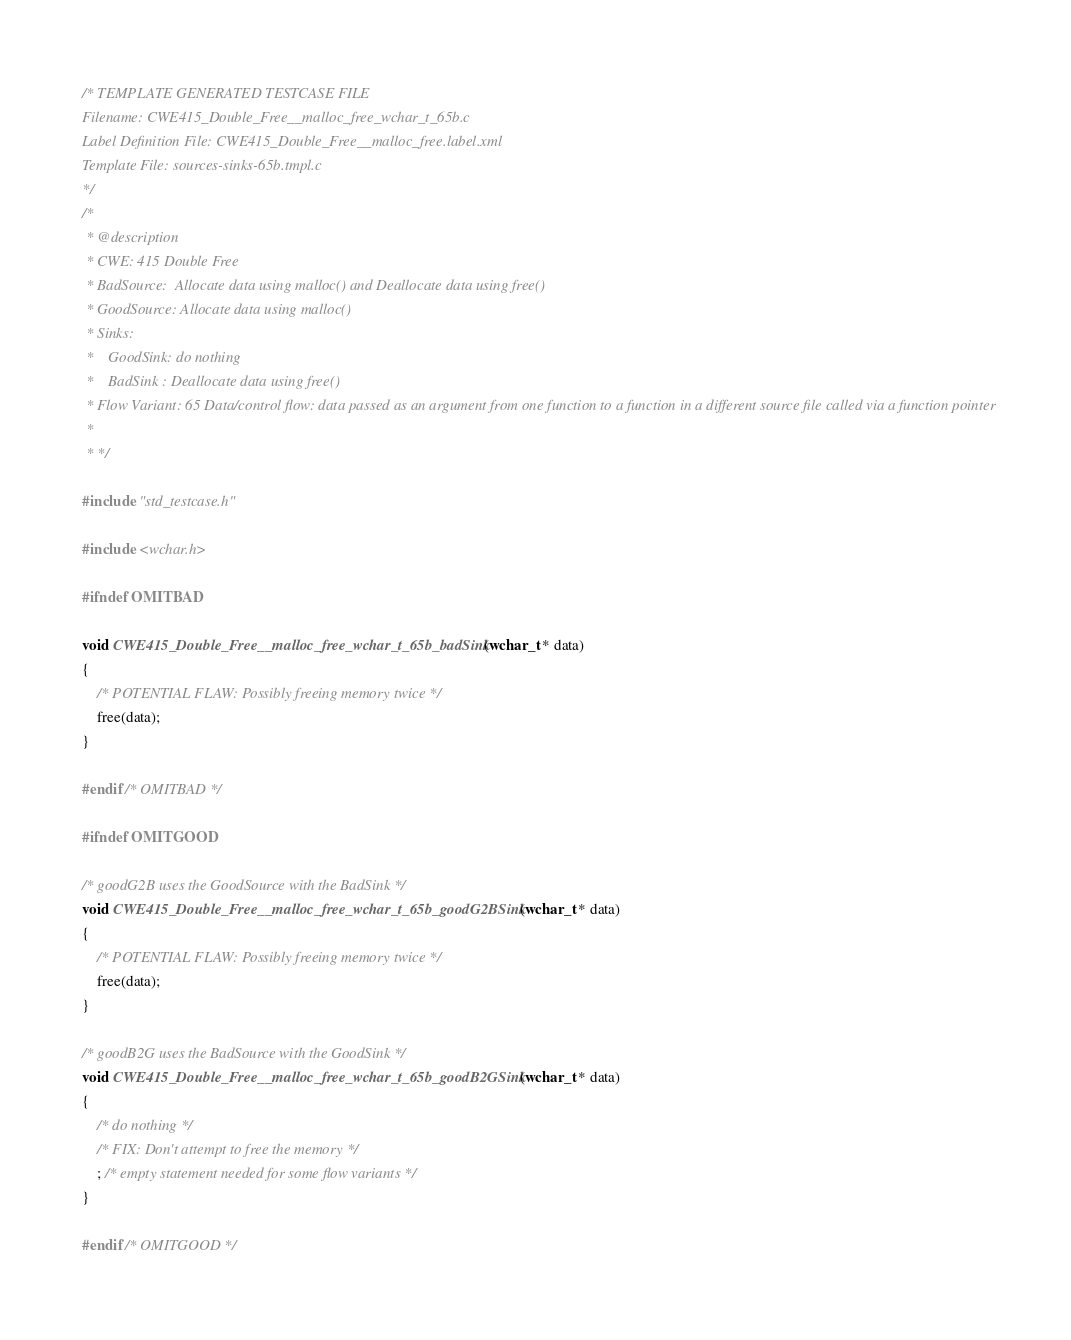<code> <loc_0><loc_0><loc_500><loc_500><_C_>/* TEMPLATE GENERATED TESTCASE FILE
Filename: CWE415_Double_Free__malloc_free_wchar_t_65b.c
Label Definition File: CWE415_Double_Free__malloc_free.label.xml
Template File: sources-sinks-65b.tmpl.c
*/
/*
 * @description
 * CWE: 415 Double Free
 * BadSource:  Allocate data using malloc() and Deallocate data using free()
 * GoodSource: Allocate data using malloc()
 * Sinks:
 *    GoodSink: do nothing
 *    BadSink : Deallocate data using free()
 * Flow Variant: 65 Data/control flow: data passed as an argument from one function to a function in a different source file called via a function pointer
 *
 * */

#include "std_testcase.h"

#include <wchar.h>

#ifndef OMITBAD

void CWE415_Double_Free__malloc_free_wchar_t_65b_badSink(wchar_t * data)
{
    /* POTENTIAL FLAW: Possibly freeing memory twice */
    free(data);
}

#endif /* OMITBAD */

#ifndef OMITGOOD

/* goodG2B uses the GoodSource with the BadSink */
void CWE415_Double_Free__malloc_free_wchar_t_65b_goodG2BSink(wchar_t * data)
{
    /* POTENTIAL FLAW: Possibly freeing memory twice */
    free(data);
}

/* goodB2G uses the BadSource with the GoodSink */
void CWE415_Double_Free__malloc_free_wchar_t_65b_goodB2GSink(wchar_t * data)
{
    /* do nothing */
    /* FIX: Don't attempt to free the memory */
    ; /* empty statement needed for some flow variants */
}

#endif /* OMITGOOD */
</code> 